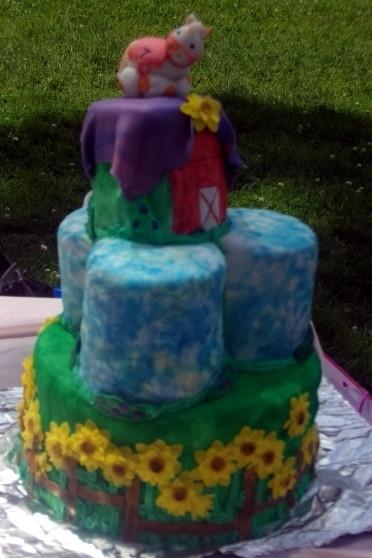Is this an adult or a child's cake?
Be succinct. Child. What color are the flowers on the bottom layer?
Write a very short answer. Yellow. Is the middle section just very large marshmallows?
Answer briefly. Yes. 